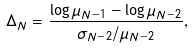<formula> <loc_0><loc_0><loc_500><loc_500>\Delta _ { N } = \frac { \log \mu _ { N - 1 } - \log \mu _ { N - 2 } } { \sigma _ { N - 2 } / \mu _ { N - 2 } } ,</formula> 